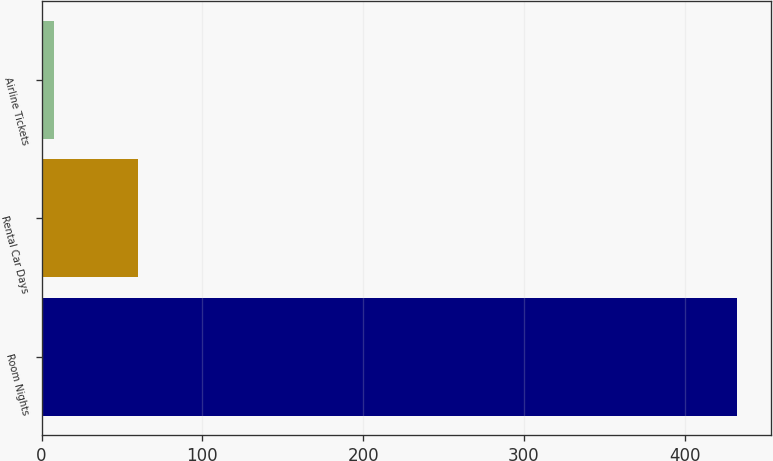Convert chart to OTSL. <chart><loc_0><loc_0><loc_500><loc_500><bar_chart><fcel>Room Nights<fcel>Rental Car Days<fcel>Airline Tickets<nl><fcel>432.3<fcel>59.9<fcel>7.7<nl></chart> 